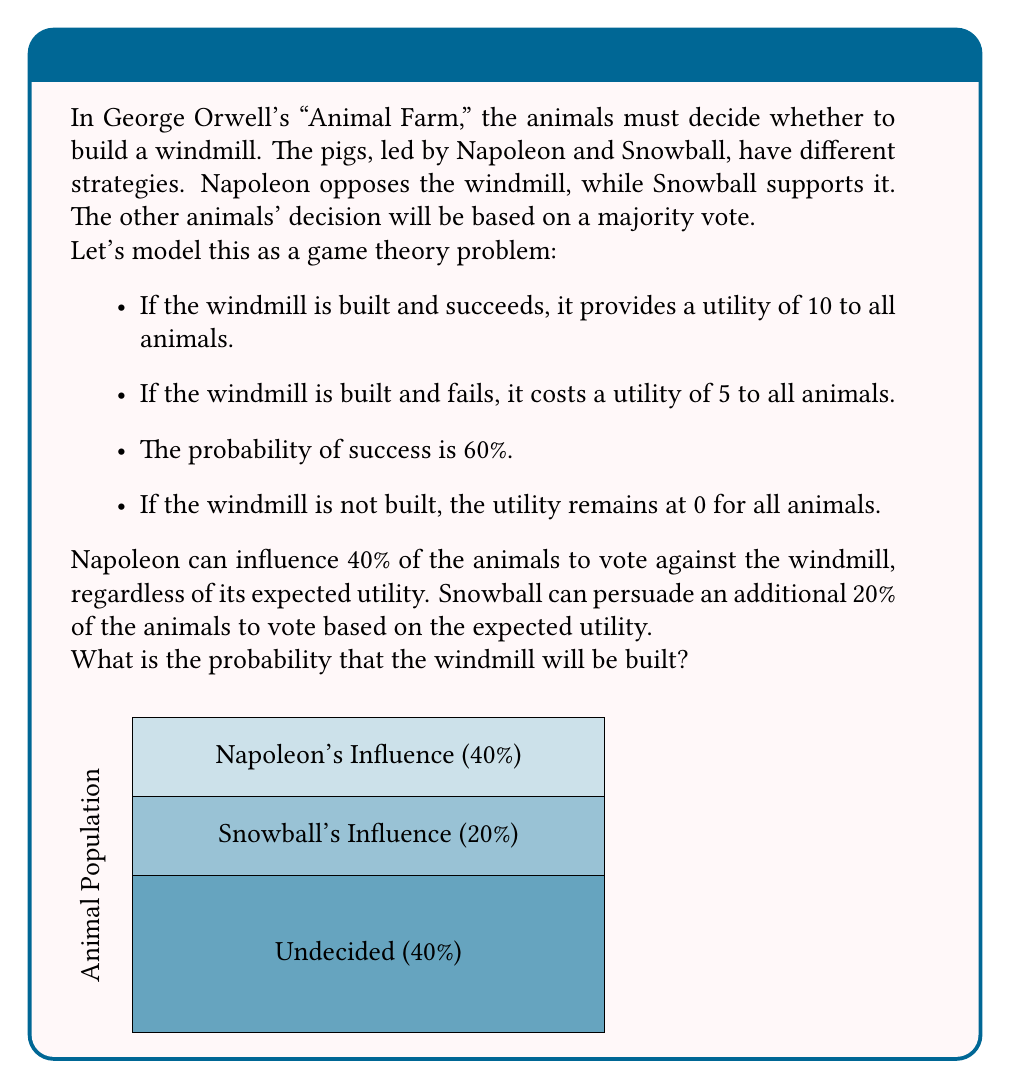Could you help me with this problem? Let's approach this step-by-step:

1) First, calculate the expected utility of building the windmill:
   $E(\text{utility}) = 0.6 \times 10 + 0.4 \times (-5) = 6 - 2 = 4$

2) Since the expected utility is positive, the 20% influenced by Snowball will vote for the windmill.

3) The remaining 40% (undecided) will also vote for the windmill based on positive expected utility.

4) Now, let's break down the voting population:
   - 40% will vote against the windmill (Napoleon's influence)
   - 60% will vote for the windmill (20% Snowball + 40% undecided)

5) For the windmill to be built, we need a majority vote, which is anything more than 50%.

6) Since 60% > 50%, the windmill will be built.

7) The probability of the windmill being built is thus 100%, or 1.
Answer: 1 